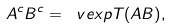Convert formula to latex. <formula><loc_0><loc_0><loc_500><loc_500>A ^ { c } B ^ { c } = \ v e x p { T ( A B ) } ,</formula> 